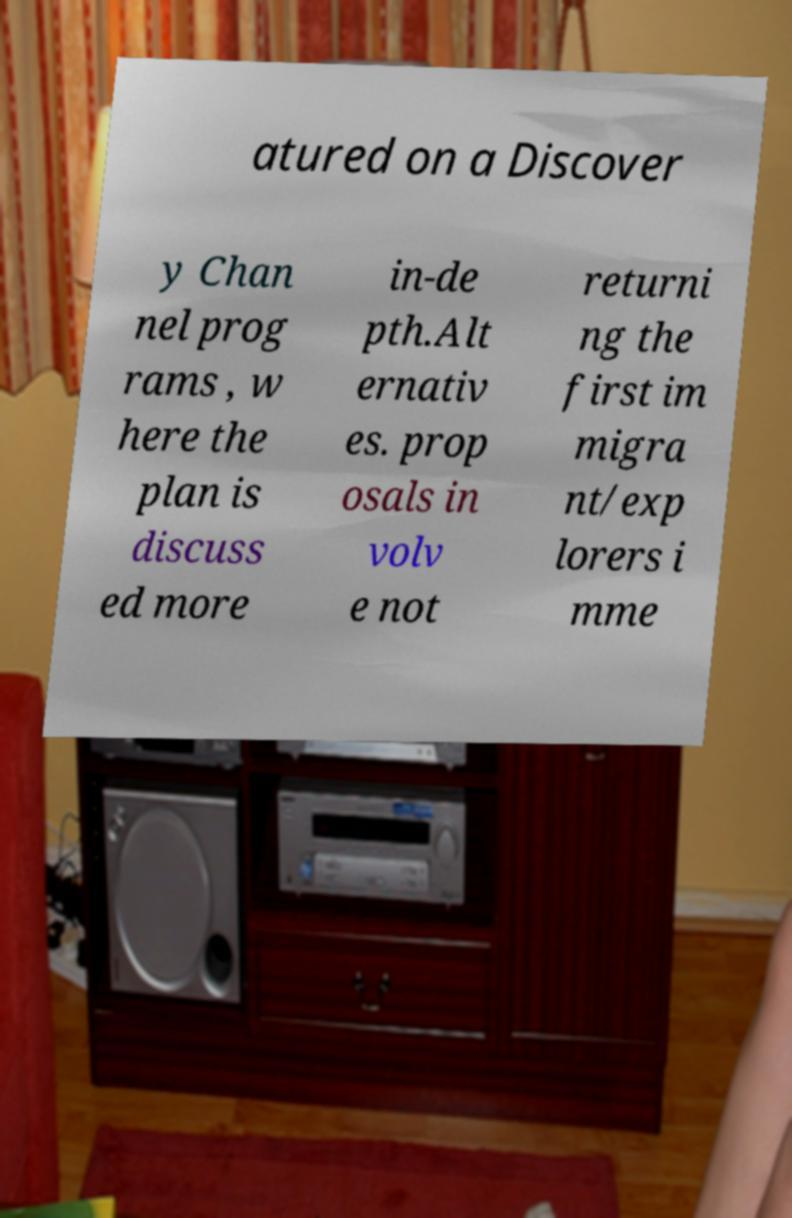I need the written content from this picture converted into text. Can you do that? atured on a Discover y Chan nel prog rams , w here the plan is discuss ed more in-de pth.Alt ernativ es. prop osals in volv e not returni ng the first im migra nt/exp lorers i mme 